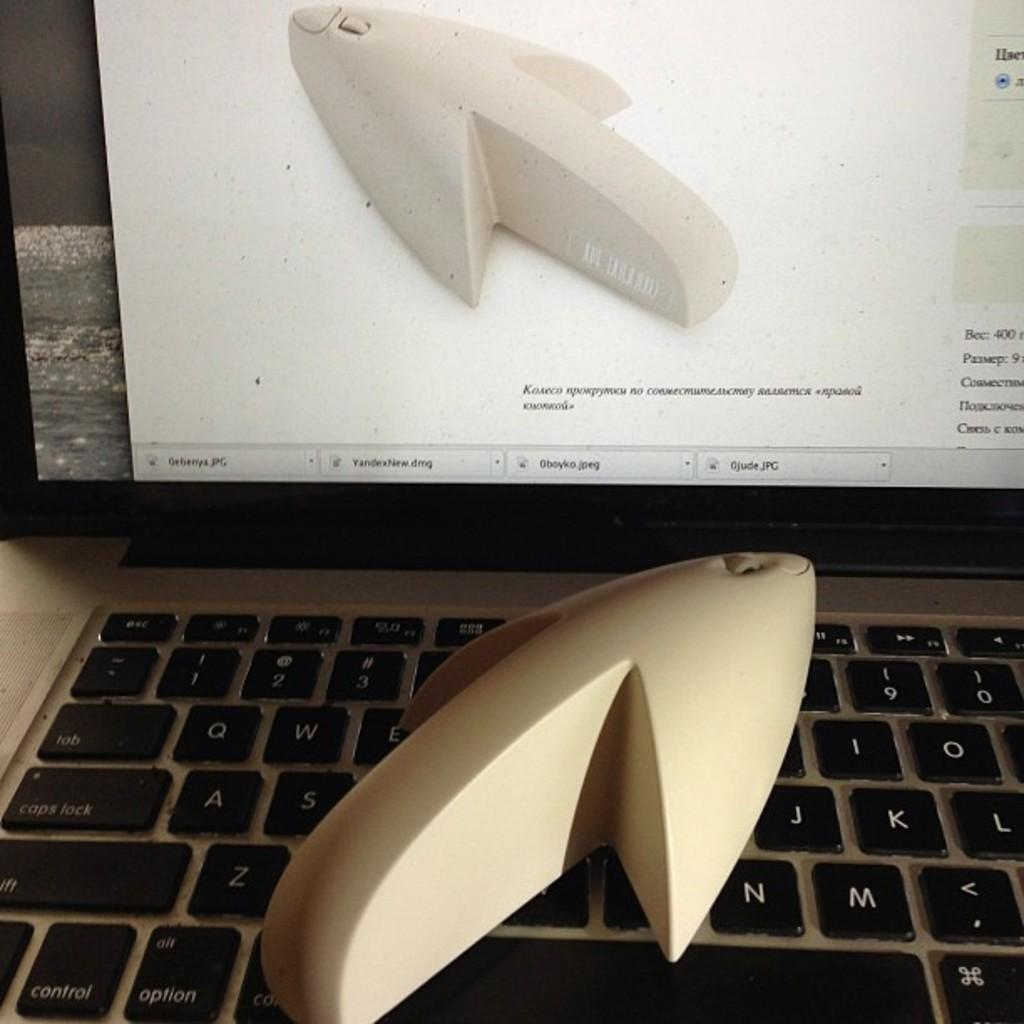<image>
Provide a brief description of the given image. A strange white object sits on a keyboard near the option and control keys. 